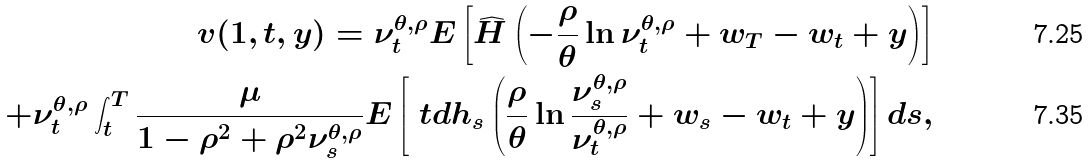Convert formula to latex. <formula><loc_0><loc_0><loc_500><loc_500>v ( 1 , t , y ) = \nu _ { t } ^ { \theta , \rho } E \left [ \widehat { H } \left ( - \frac { \rho } { \theta } \ln \nu _ { t } ^ { \theta , \rho } + w _ { T } - w _ { t } + y \right ) \right ] \\ + \nu _ { t } ^ { \theta , \rho } \int _ { t } ^ { T } \frac { \mu } { 1 - \rho ^ { 2 } + \rho ^ { 2 } \nu _ { s } ^ { \theta , \rho } } E \left [ \ t d { h } _ { s } \left ( \frac { \rho } { \theta } \ln \frac { \nu _ { s } ^ { \theta , \rho } } { \nu _ { t } ^ { \theta , \rho } } + w _ { s } - w _ { t } + y \right ) \right ] d s ,</formula> 